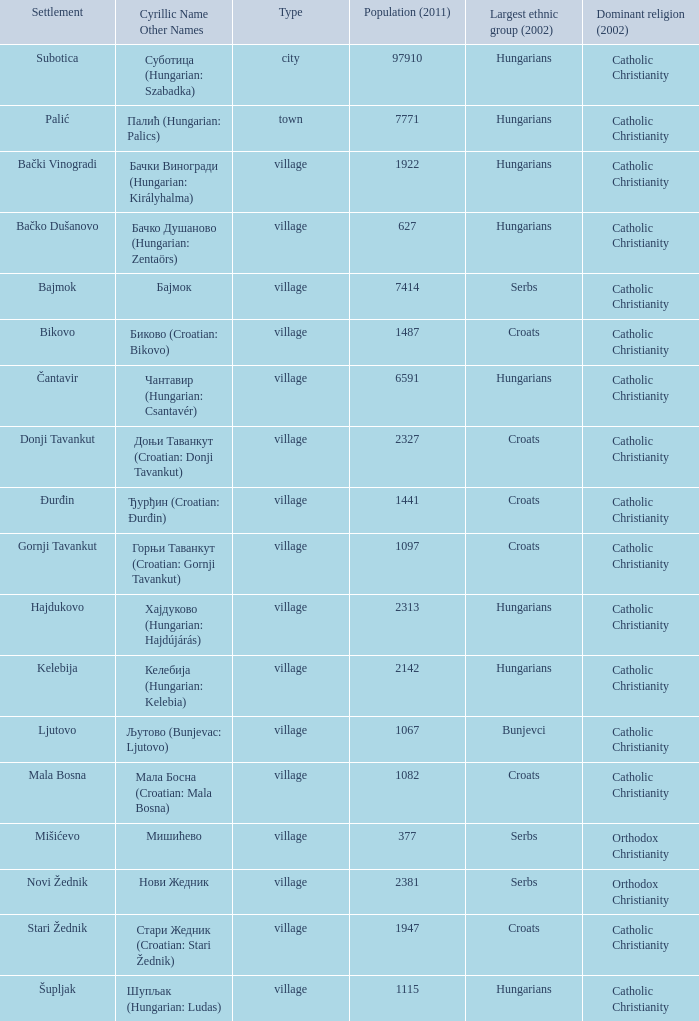In stari žednik (croatian: стари жедник), what is the total population? 1947.0. 